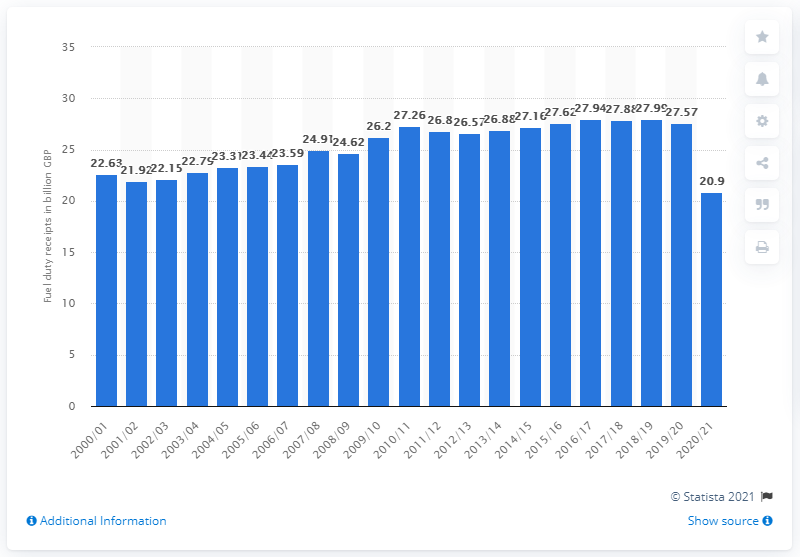Outline some significant characteristics in this image. In the previous financial year, the amount of fuel duty tax receipts was 27.99. 